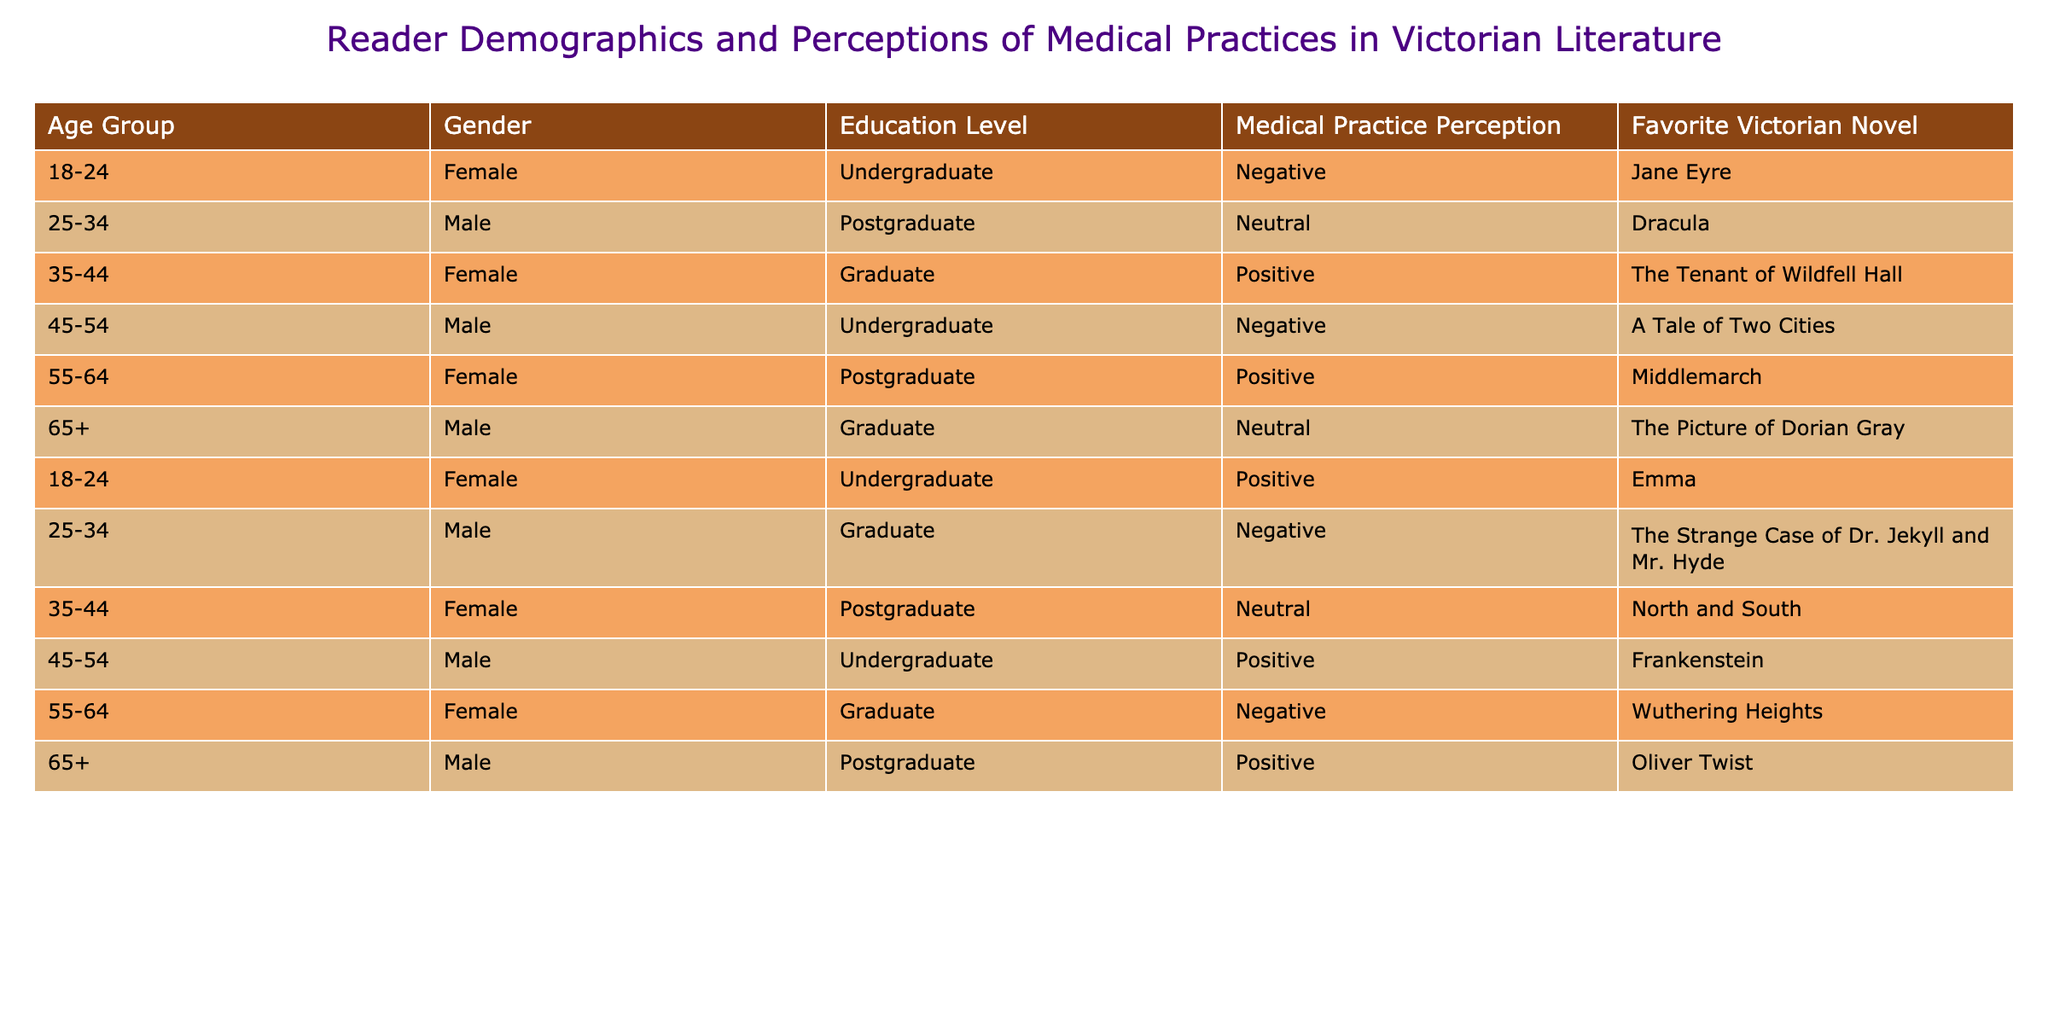What is the favorite Victorian novel of individuals aged 55-64 with a negative perception of medical practices? There is one individual aged 55-64 with a negative perception who cites Wuthering Heights as their favorite Victorian novel.
Answer: Wuthering Heights How many males have a positive perception of medical practices? By analyzing the table, we see that there are three males who have a positive perception of medical practices: one aged 35-44 who prefers Frankenstein, one aged 55-64 who favors Oliver Twist, and another aged 18-24 who enjoys Emma. Therefore, the total count is three.
Answer: 3 What is the favorite Victorian novel among individuals who perceive medical practices as neutral? Three individuals have a neutral perception: one aged 25-34 who likes Dracula, one aged 35-44 who enjoys North and South, and one aged 65+ who prefers The Picture of Dorian Gray. Thus, there are three favorite novels for this perception category.
Answer: Dracula, North and South, The Picture of Dorian Gray Do any females aged 35-44 have a negative perception of medical practices? Reviewing the data, I find that there are no females in the 35-44 age group with a negative perception of medical practices. Therefore, the answer is no.
Answer: No What is the average age of individuals who view medical practices positively? To calculate the average age, I identify the ages of the individuals with a positive perception, which are 35-44 (average age of 39.5), 55-64 (average age of 59.5), and 18-24 (average age of 21).  Considering their age representation: (39.5 + 59.5 + 21) / 3 = 40.33, which is the average age of individuals with a positive perception.
Answer: 40.33 